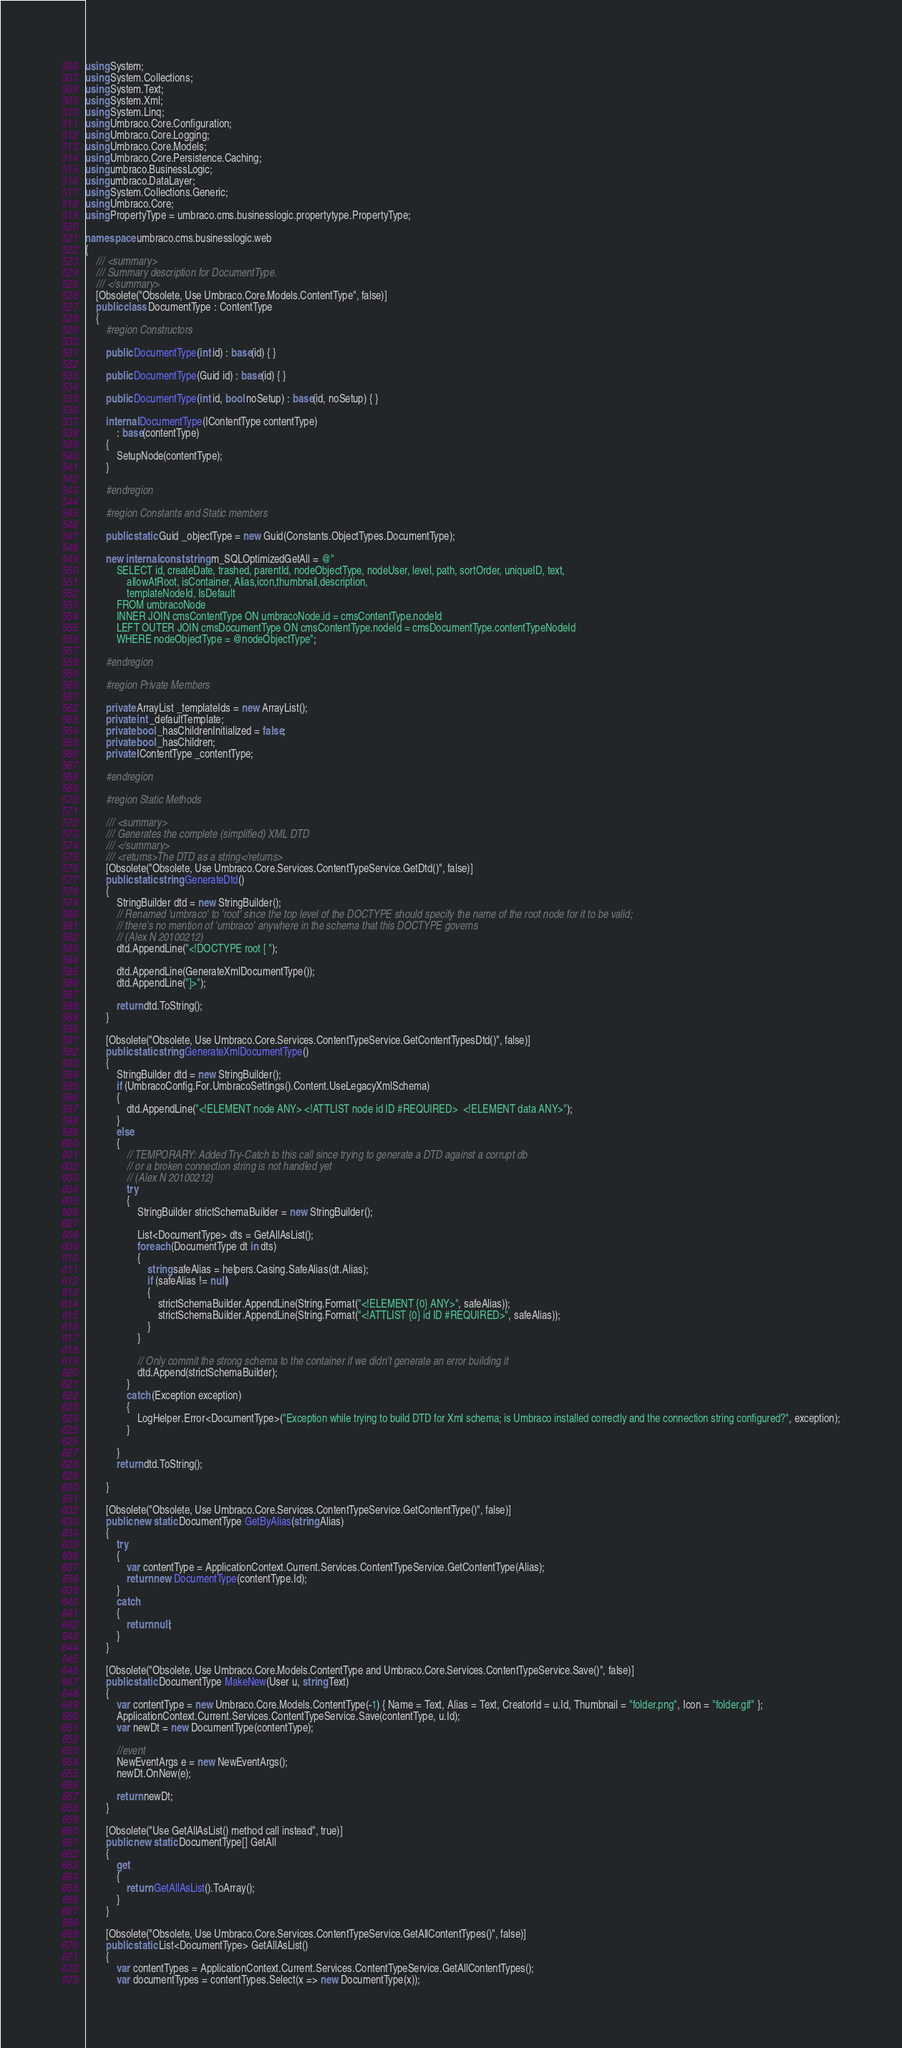<code> <loc_0><loc_0><loc_500><loc_500><_C#_>using System;
using System.Collections;
using System.Text;
using System.Xml;
using System.Linq;
using Umbraco.Core.Configuration;
using Umbraco.Core.Logging;
using Umbraco.Core.Models;
using Umbraco.Core.Persistence.Caching;
using umbraco.BusinessLogic;
using umbraco.DataLayer;
using System.Collections.Generic;
using Umbraco.Core;
using PropertyType = umbraco.cms.businesslogic.propertytype.PropertyType;

namespace umbraco.cms.businesslogic.web
{
    /// <summary>
    /// Summary description for DocumentType.
    /// </summary>
    [Obsolete("Obsolete, Use Umbraco.Core.Models.ContentType", false)]
    public class DocumentType : ContentType
    {
        #region Constructors

        public DocumentType(int id) : base(id) { }

        public DocumentType(Guid id) : base(id) { }

        public DocumentType(int id, bool noSetup) : base(id, noSetup) { }

        internal DocumentType(IContentType contentType)
            : base(contentType)
        {
            SetupNode(contentType);
        }

        #endregion

        #region Constants and Static members

        public static Guid _objectType = new Guid(Constants.ObjectTypes.DocumentType);

        new internal const string m_SQLOptimizedGetAll = @"
            SELECT id, createDate, trashed, parentId, nodeObjectType, nodeUser, level, path, sortOrder, uniqueID, text,
                allowAtRoot, isContainer, Alias,icon,thumbnail,description,
                templateNodeId, IsDefault
            FROM umbracoNode 
            INNER JOIN cmsContentType ON umbracoNode.id = cmsContentType.nodeId
            LEFT OUTER JOIN cmsDocumentType ON cmsContentType.nodeId = cmsDocumentType.contentTypeNodeId
            WHERE nodeObjectType = @nodeObjectType";

        #endregion

        #region Private Members

        private ArrayList _templateIds = new ArrayList();
        private int _defaultTemplate;
        private bool _hasChildrenInitialized = false;
        private bool _hasChildren;
        private IContentType _contentType;

        #endregion

        #region Static Methods

        /// <summary>
        /// Generates the complete (simplified) XML DTD 
        /// </summary>
        /// <returns>The DTD as a string</returns>
        [Obsolete("Obsolete, Use Umbraco.Core.Services.ContentTypeService.GetDtd()", false)]
        public static string GenerateDtd()
        {
            StringBuilder dtd = new StringBuilder();
            // Renamed 'umbraco' to 'root' since the top level of the DOCTYPE should specify the name of the root node for it to be valid;
            // there's no mention of 'umbraco' anywhere in the schema that this DOCTYPE governs
            // (Alex N 20100212)
            dtd.AppendLine("<!DOCTYPE root [ ");

            dtd.AppendLine(GenerateXmlDocumentType());
            dtd.AppendLine("]>");

            return dtd.ToString();
        }

        [Obsolete("Obsolete, Use Umbraco.Core.Services.ContentTypeService.GetContentTypesDtd()", false)]
        public static string GenerateXmlDocumentType()
        {
            StringBuilder dtd = new StringBuilder();
            if (UmbracoConfig.For.UmbracoSettings().Content.UseLegacyXmlSchema)
            {
                dtd.AppendLine("<!ELEMENT node ANY> <!ATTLIST node id ID #REQUIRED>  <!ELEMENT data ANY>");
            }
            else
            {
                // TEMPORARY: Added Try-Catch to this call since trying to generate a DTD against a corrupt db
                // or a broken connection string is not handled yet
                // (Alex N 20100212)
                try
                {
                    StringBuilder strictSchemaBuilder = new StringBuilder();

                    List<DocumentType> dts = GetAllAsList();
                    foreach (DocumentType dt in dts)
                    {
                        string safeAlias = helpers.Casing.SafeAlias(dt.Alias);
                        if (safeAlias != null)
                        {
                            strictSchemaBuilder.AppendLine(String.Format("<!ELEMENT {0} ANY>", safeAlias));
                            strictSchemaBuilder.AppendLine(String.Format("<!ATTLIST {0} id ID #REQUIRED>", safeAlias));
                        }
                    }

                    // Only commit the strong schema to the container if we didn't generate an error building it
                    dtd.Append(strictSchemaBuilder);
                }
                catch (Exception exception)
                {
                    LogHelper.Error<DocumentType>("Exception while trying to build DTD for Xml schema; is Umbraco installed correctly and the connection string configured?", exception);
                }

            }
            return dtd.ToString();

        }

        [Obsolete("Obsolete, Use Umbraco.Core.Services.ContentTypeService.GetContentType()", false)]
        public new static DocumentType GetByAlias(string Alias)
        {
            try
            {
                var contentType = ApplicationContext.Current.Services.ContentTypeService.GetContentType(Alias);
                return new DocumentType(contentType.Id);
            }
            catch
            {
                return null;
            }
        }

        [Obsolete("Obsolete, Use Umbraco.Core.Models.ContentType and Umbraco.Core.Services.ContentTypeService.Save()", false)]
        public static DocumentType MakeNew(User u, string Text)
        {
            var contentType = new Umbraco.Core.Models.ContentType(-1) { Name = Text, Alias = Text, CreatorId = u.Id, Thumbnail = "folder.png", Icon = "folder.gif" };
            ApplicationContext.Current.Services.ContentTypeService.Save(contentType, u.Id);
            var newDt = new DocumentType(contentType);

            //event
            NewEventArgs e = new NewEventArgs();
            newDt.OnNew(e);

            return newDt;
        }

        [Obsolete("Use GetAllAsList() method call instead", true)]
        public new static DocumentType[] GetAll
        {
            get
            {
                return GetAllAsList().ToArray();
            }
        }

        [Obsolete("Obsolete, Use Umbraco.Core.Services.ContentTypeService.GetAllContentTypes()", false)]
        public static List<DocumentType> GetAllAsList()
        {
            var contentTypes = ApplicationContext.Current.Services.ContentTypeService.GetAllContentTypes();
            var documentTypes = contentTypes.Select(x => new DocumentType(x));
</code> 